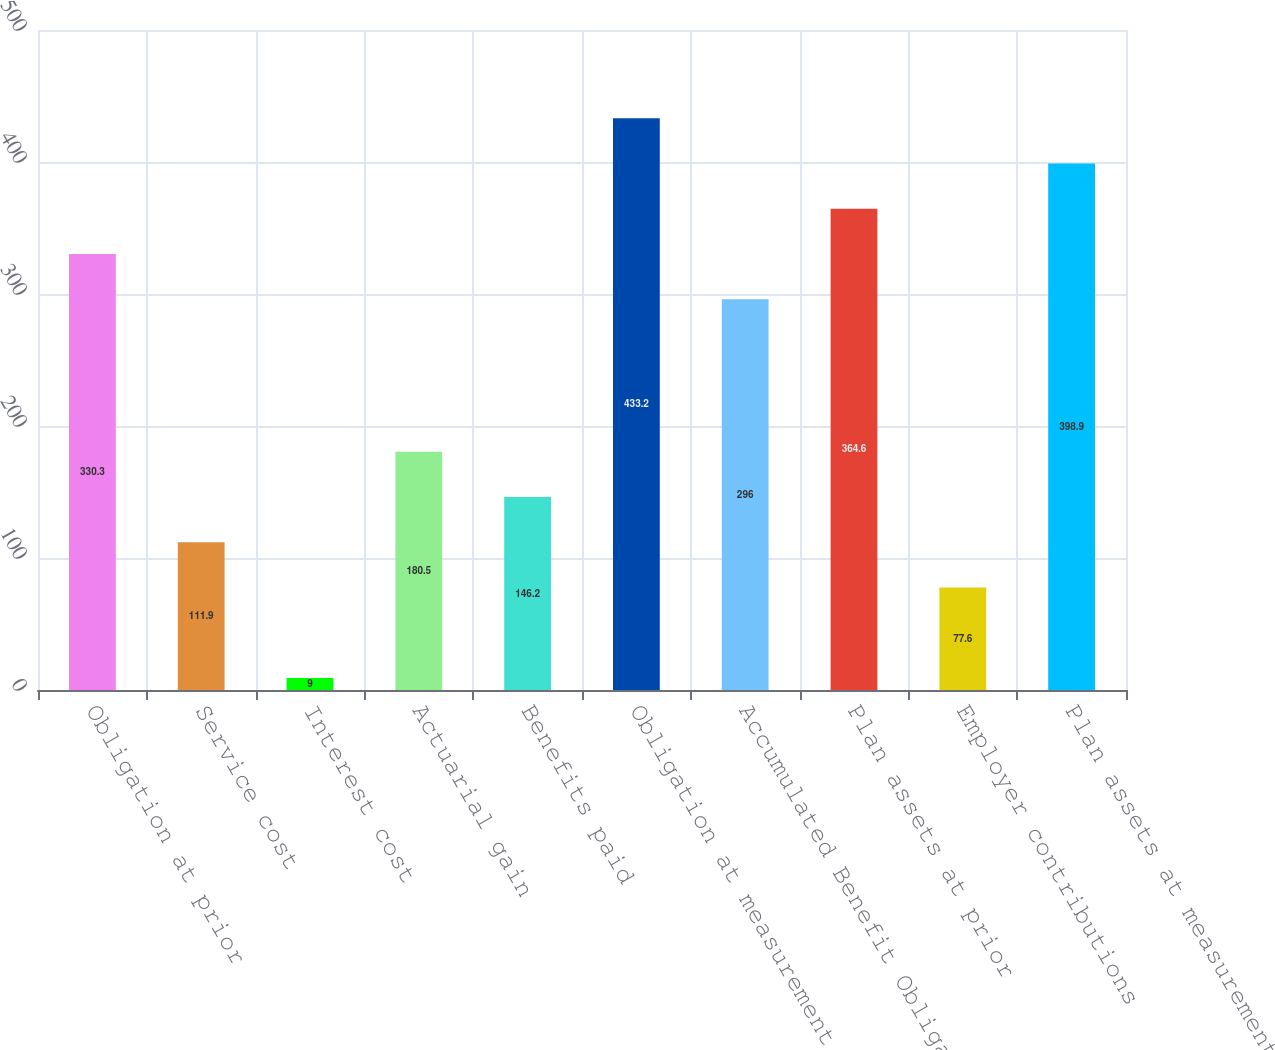<chart> <loc_0><loc_0><loc_500><loc_500><bar_chart><fcel>Obligation at prior<fcel>Service cost<fcel>Interest cost<fcel>Actuarial gain<fcel>Benefits paid<fcel>Obligation at measurement date<fcel>Accumulated Benefit Obligation<fcel>Plan assets at prior<fcel>Employer contributions<fcel>Plan assets at measurement<nl><fcel>330.3<fcel>111.9<fcel>9<fcel>180.5<fcel>146.2<fcel>433.2<fcel>296<fcel>364.6<fcel>77.6<fcel>398.9<nl></chart> 